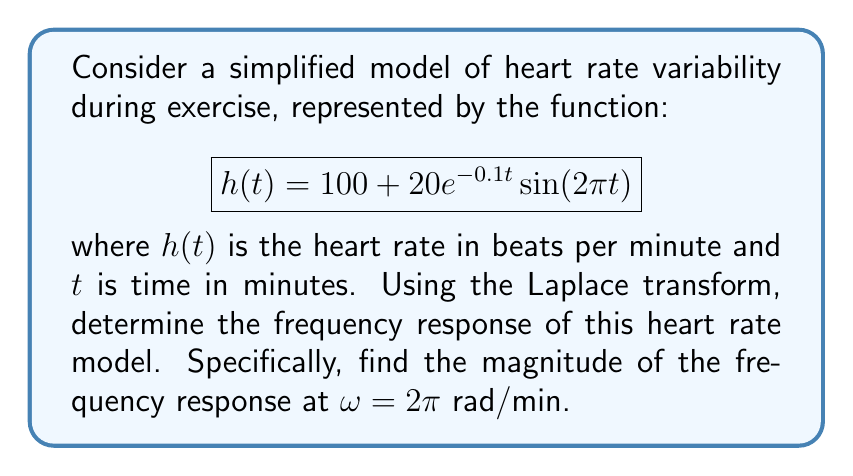Show me your answer to this math problem. To solve this problem, we'll follow these steps:

1) First, we need to find the Laplace transform of $h(t)$. The Laplace transform of a function $f(t)$ is defined as:

   $$F(s) = \mathcal{L}\{f(t)\} = \int_0^\infty f(t)e^{-st}dt$$

2) For our function $h(t)$, we can split it into two parts:
   
   $$h(t) = 100 + 20e^{-0.1t}\sin(2\pi t)$$

3) The Laplace transform of a constant is that constant divided by $s$, so:

   $$\mathcal{L}\{100\} = \frac{100}{s}$$

4) For the second part, we can use the Laplace transform of a damped sinusoid:

   $$\mathcal{L}\{e^{-at}\sin(bt)\} = \frac{b}{(s+a)^2 + b^2}$$

   In our case, $a = 0.1$ and $b = 2\pi$

5) Therefore, the Laplace transform of $h(t)$ is:

   $$H(s) = \frac{100}{s} + \frac{20(2\pi)}{(s+0.1)^2 + (2\pi)^2}$$

6) To find the frequency response, we substitute $s = j\omega$ into $H(s)$:

   $$H(j\omega) = \frac{100}{j\omega} + \frac{40\pi}{(j\omega+0.1)^2 + (2\pi)^2}$$

7) The magnitude of the frequency response is given by $|H(j\omega)|$. At $\omega = 2\pi$:

   $$|H(j2\pi)| = \left|\frac{100}{j2\pi} + \frac{40\pi}{(j2\pi+0.1)^2 + (2\pi)^2}\right|$$

8) Simplifying:

   $$|H(j2\pi)| = \sqrt{\left(\frac{100}{2\pi}\right)^2 + \left(\frac{40\pi}{(2\pi)^2 + 0.01}\right)^2}$$

9) Calculating this value:

   $$|H(j2\pi)| \approx 15.92$$

This value represents the magnitude of the heart rate variation at a frequency of 1 cycle per minute.
Answer: The magnitude of the frequency response at $\omega = 2\pi$ rad/min is approximately 15.92. 